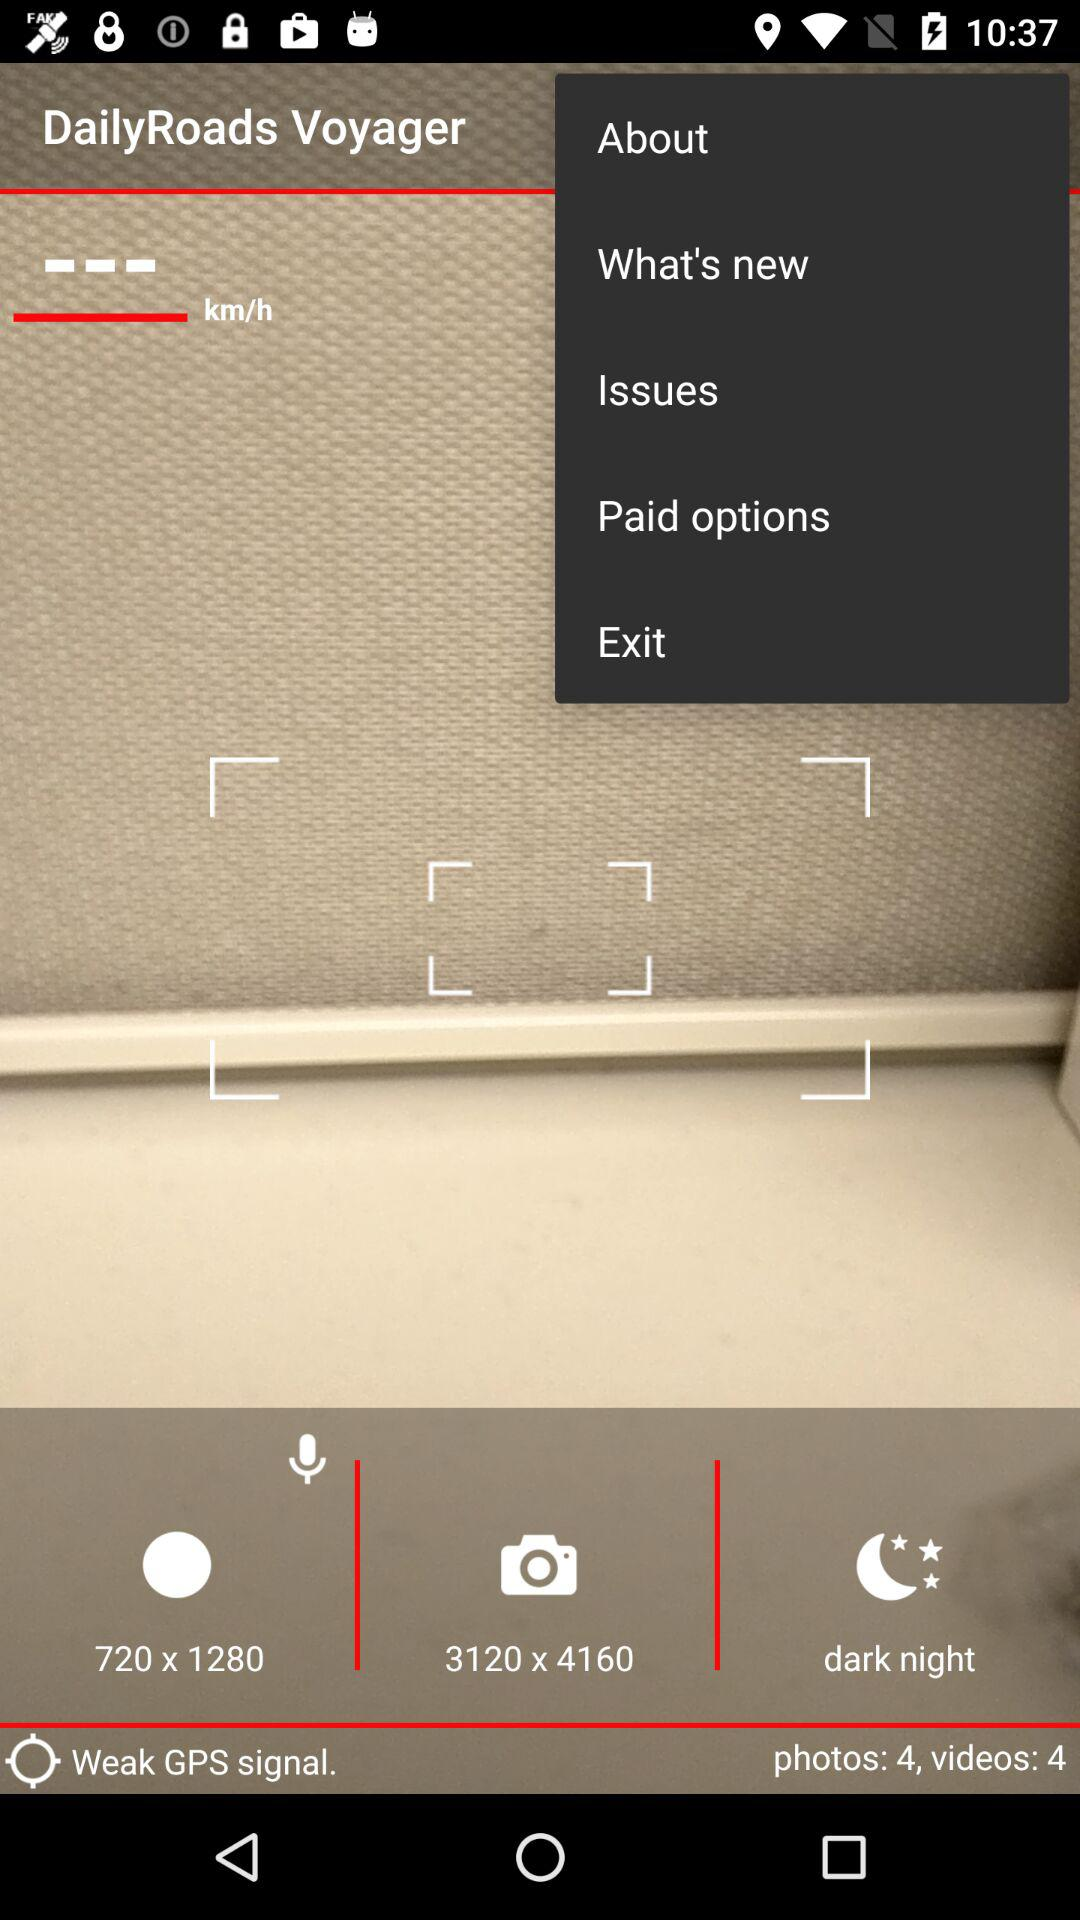What is the total number of photos? The total number of photos is 4. 